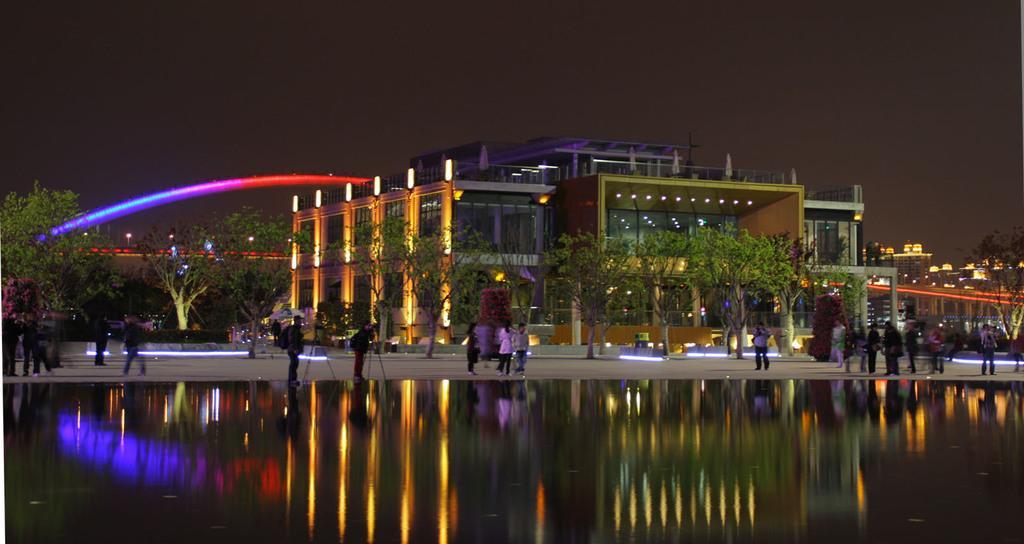Describe this image in one or two sentences. In front of the image there is water. There are people standing on the road. In the background of the image there are trees, bushes, buildings, light poles, bridge and some other objects. At the top of the image there is sky. 